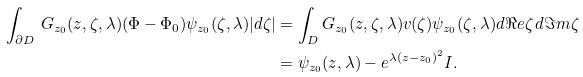<formula> <loc_0><loc_0><loc_500><loc_500>\int _ { \partial D } \, G _ { z _ { 0 } } ( z , \zeta , \lambda ) ( \Phi - \Phi _ { 0 } ) \psi _ { z _ { 0 } } ( \zeta , \lambda ) | d \zeta | & = \int _ { D } G _ { z _ { 0 } } ( z , \zeta , \lambda ) v ( \zeta ) \psi _ { z _ { 0 } } ( \zeta , \lambda ) d \Re e \zeta \, d \Im m \zeta \\ & = \psi _ { z _ { 0 } } ( z , \lambda ) - e ^ { \lambda ( z - z _ { 0 } ) ^ { 2 } } I .</formula> 